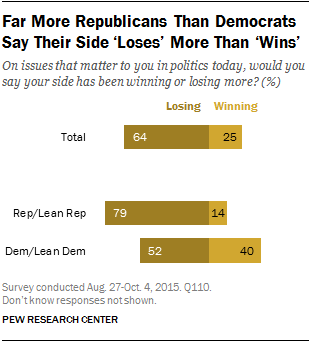Mention a couple of crucial points in this snapshot. The value of the second yellow bar from the top is 14. The sum of all the yellow bars above 20 is 65. 